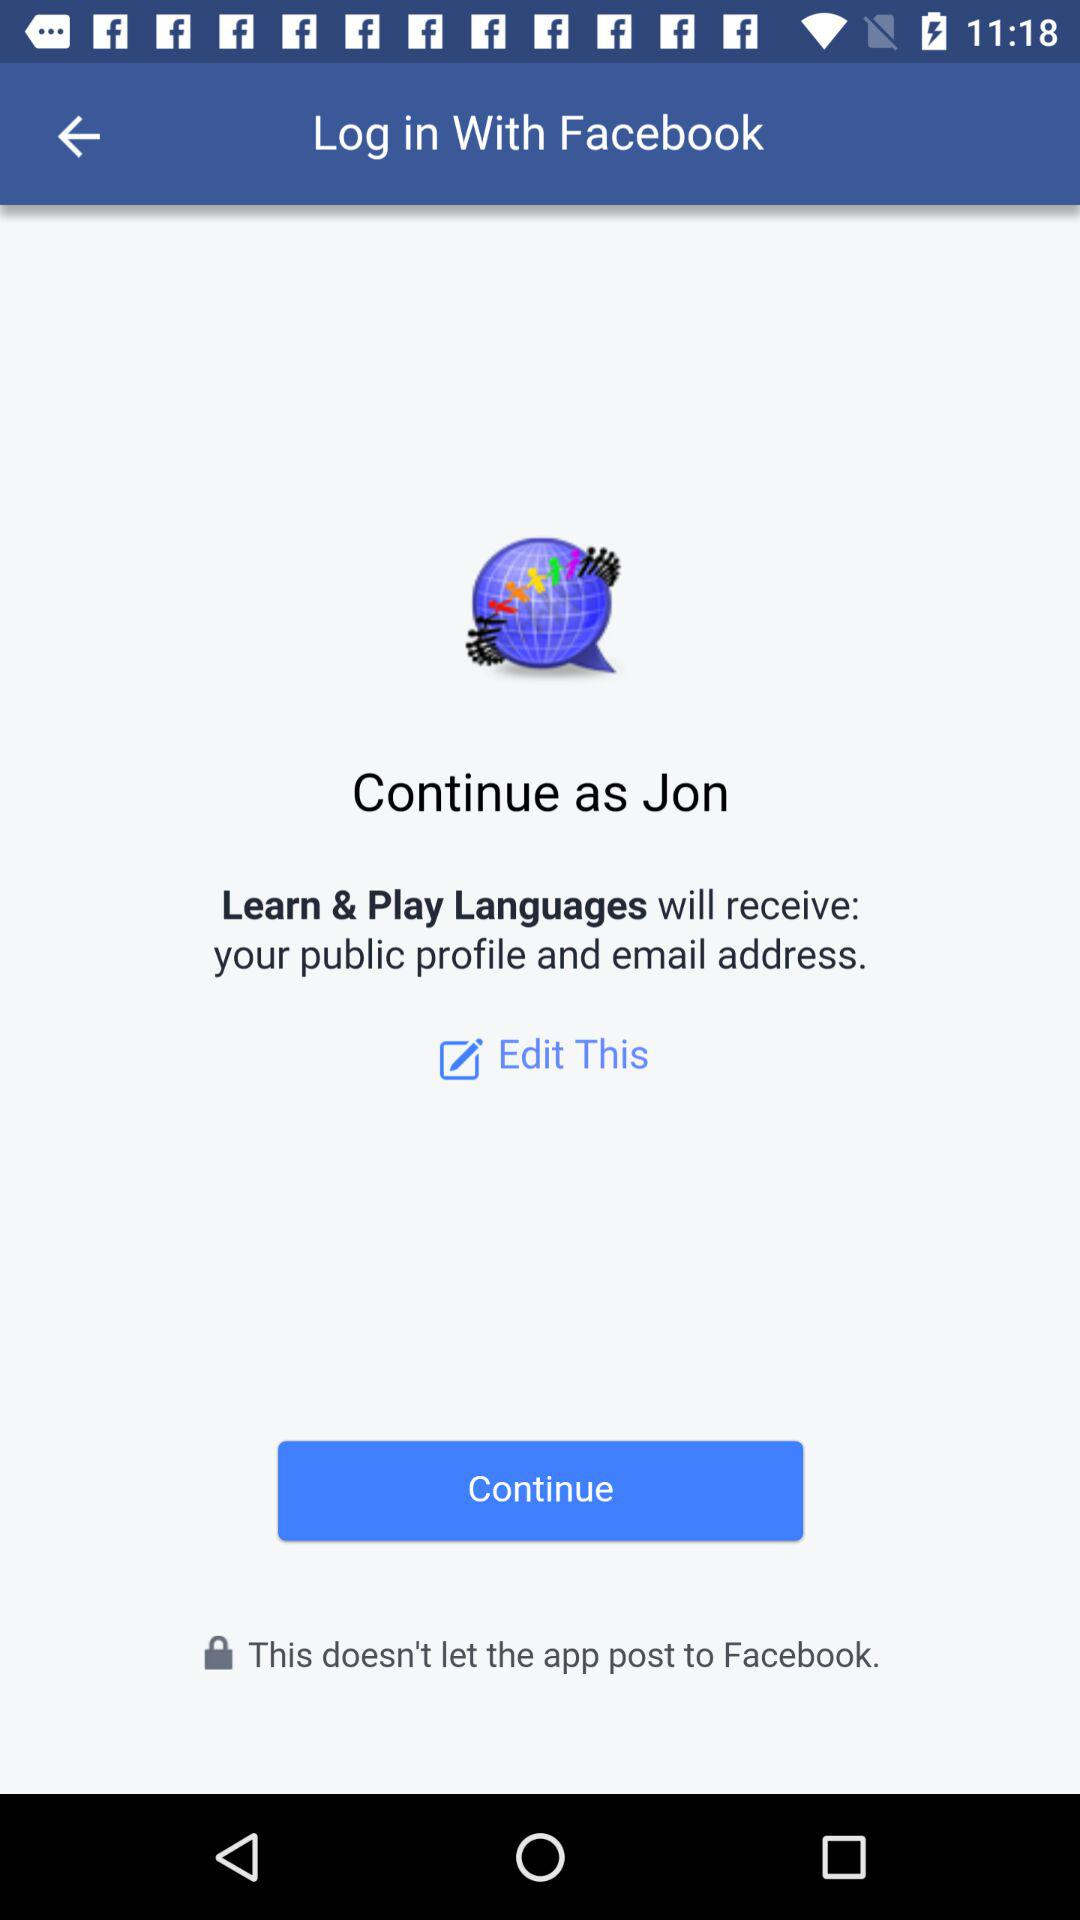What application is asking for permission? The application asking for permission is "Learn & Play Languages". 